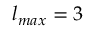<formula> <loc_0><loc_0><loc_500><loc_500>l _ { \max } = 3</formula> 